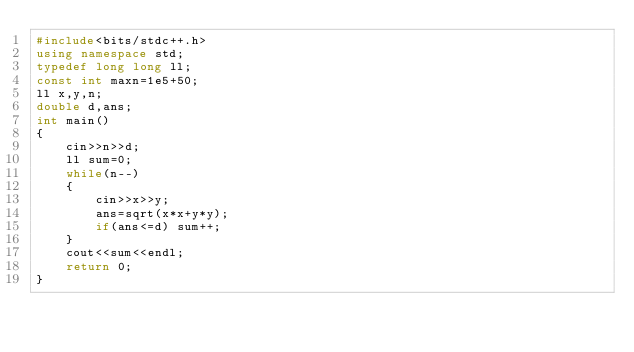Convert code to text. <code><loc_0><loc_0><loc_500><loc_500><_C++_>#include<bits/stdc++.h>
using namespace std;
typedef long long ll;
const int maxn=1e5+50;
ll x,y,n;
double d,ans;
int main()
{
    cin>>n>>d;
    ll sum=0;
    while(n--)
    {
        cin>>x>>y;
        ans=sqrt(x*x+y*y);
        if(ans<=d) sum++;
    }
    cout<<sum<<endl;
    return 0;
}</code> 